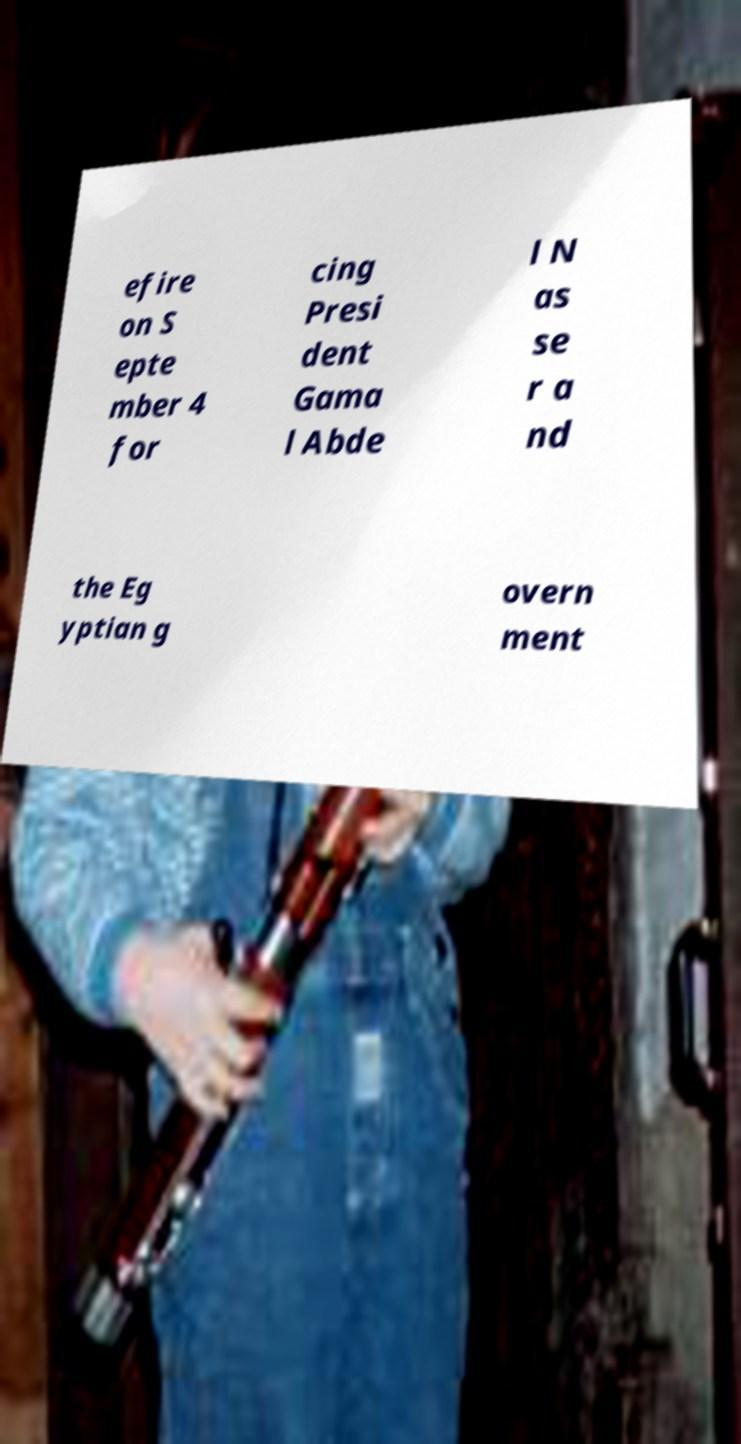Please identify and transcribe the text found in this image. efire on S epte mber 4 for cing Presi dent Gama l Abde l N as se r a nd the Eg yptian g overn ment 